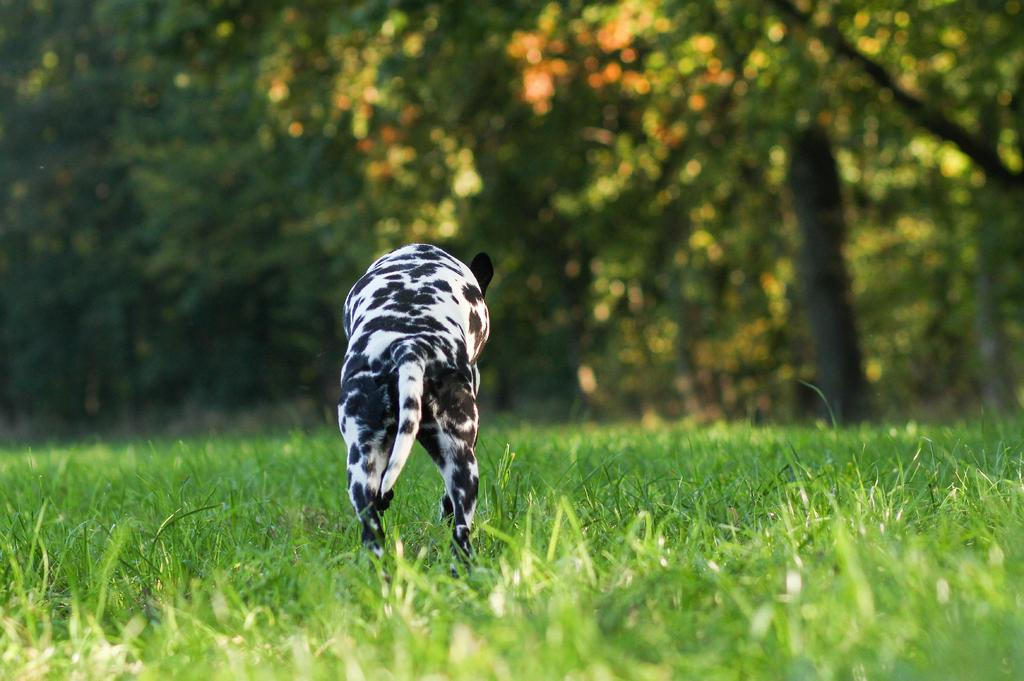What type of animal is in the image? The type of animal cannot be determined from the provided facts. What is at the bottom of the image? There is green grass at the bottom of the image. What can be seen in the background of the image? There are trees in the background of the image. What type of snow can be seen falling in the image? There is no snow present in the image; it features green grass and trees. What is the animal's relation to the trees in the image? The animal's relation to the trees cannot be determined from the provided facts. 